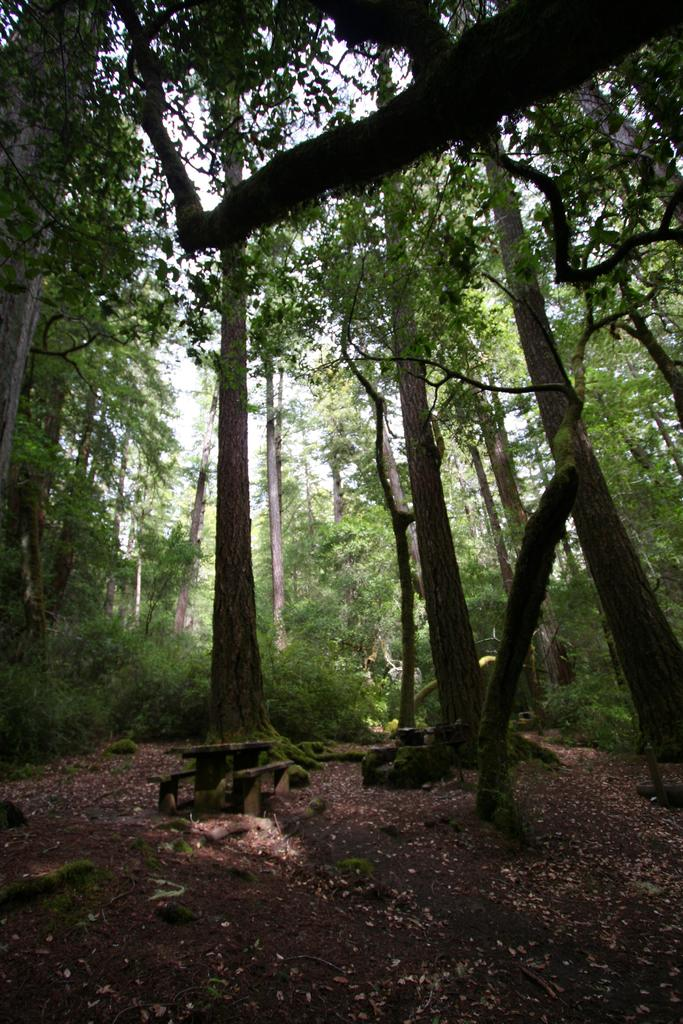What type of vegetation can be seen in the image? There are trees and plants in the image. What part of the natural environment is visible in the image? The sky is visible in the image. Can you describe the vegetation in the image? The image contains trees and plants, which are both types of vegetation. What type of pollution can be seen in the image? There is no pollution visible in the image; it features trees, plants, and the sky. What process is being carried out in the image? There is no specific process being carried out in the image; it simply shows trees, plants, and the sky. 